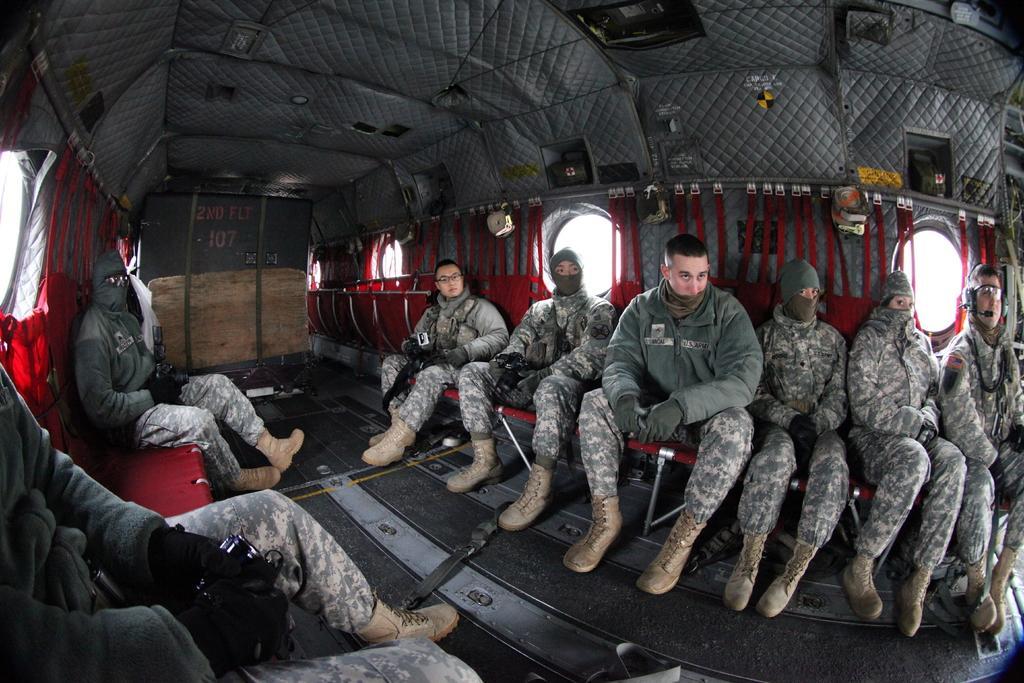In one or two sentences, can you explain what this image depicts? This is an inside view of the vehicle, in this image on the right side and left side there are some people who are sitting and in the center there is one board. On the top there is some cloth and on the right side and left side there are some windows. 